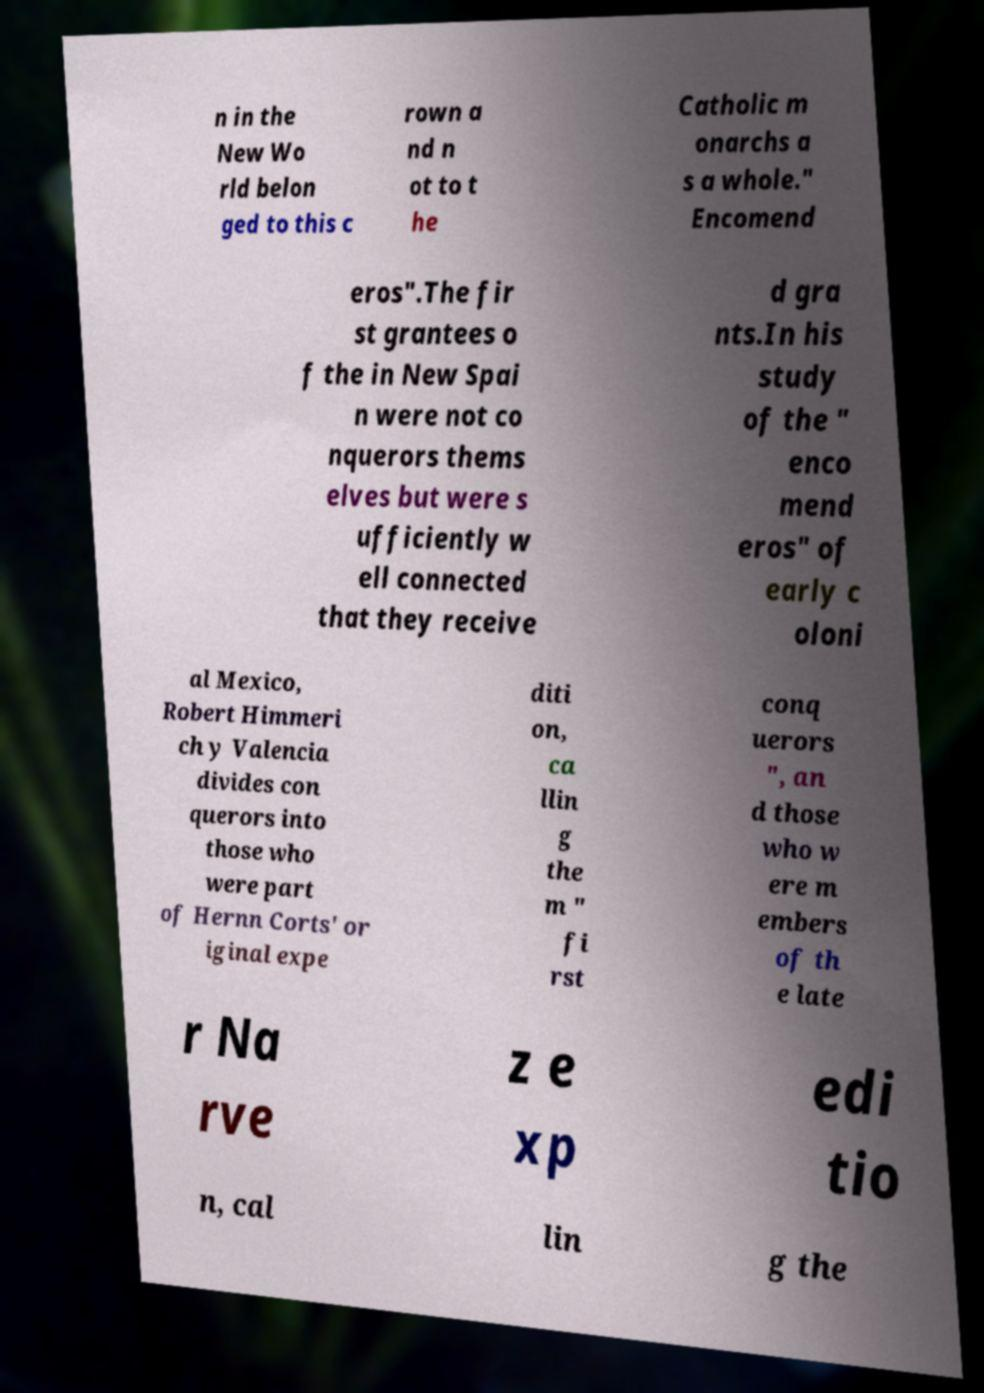For documentation purposes, I need the text within this image transcribed. Could you provide that? n in the New Wo rld belon ged to this c rown a nd n ot to t he Catholic m onarchs a s a whole." Encomend eros".The fir st grantees o f the in New Spai n were not co nquerors thems elves but were s ufficiently w ell connected that they receive d gra nts.In his study of the " enco mend eros" of early c oloni al Mexico, Robert Himmeri ch y Valencia divides con querors into those who were part of Hernn Corts' or iginal expe diti on, ca llin g the m " fi rst conq uerors ", an d those who w ere m embers of th e late r Na rve z e xp edi tio n, cal lin g the 